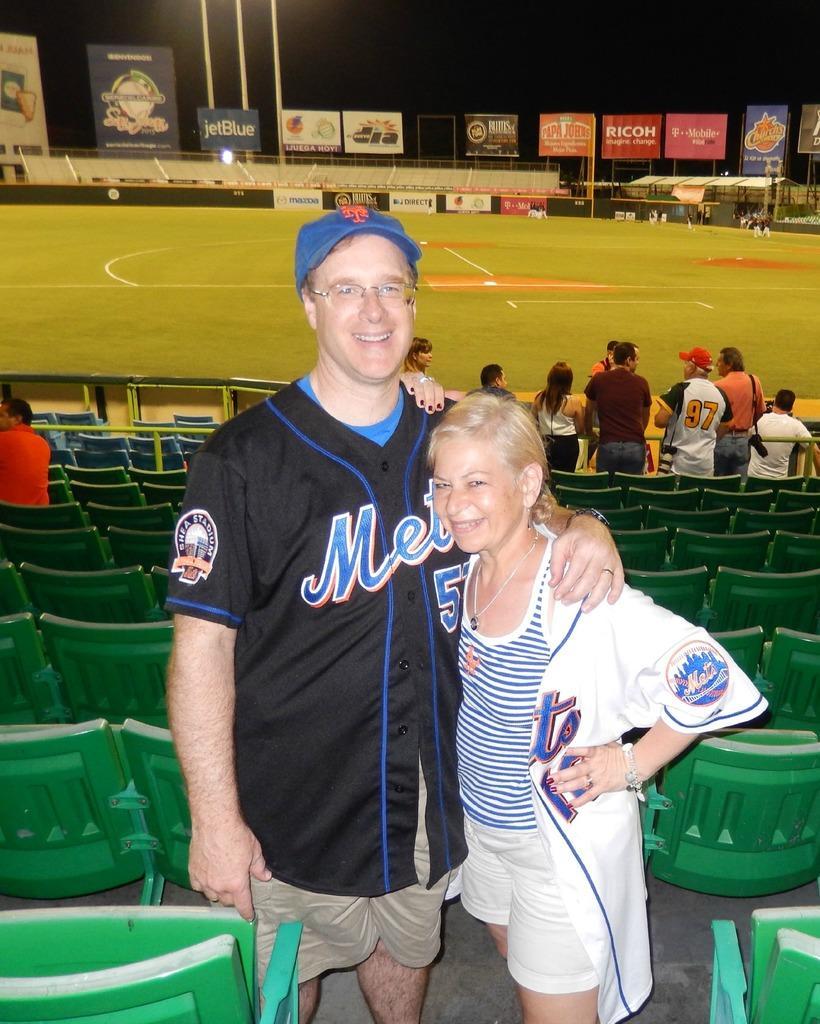Could you give a brief overview of what you see in this image? In this image, I can see the man and woman standing and smiling. These are the chairs. On the right side of the image, there are group of people standing. This looks like a ground. At the top of the image, I can see the hoardings. On the left side of the image, I can see another person standing. 